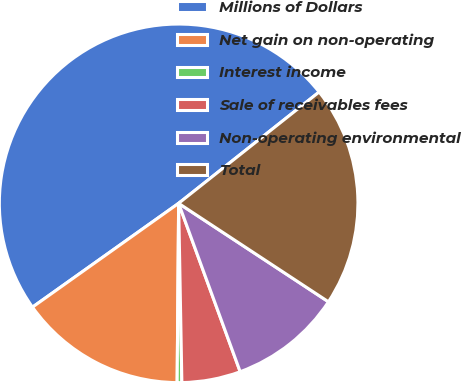<chart> <loc_0><loc_0><loc_500><loc_500><pie_chart><fcel>Millions of Dollars<fcel>Net gain on non-operating<fcel>Interest income<fcel>Sale of receivables fees<fcel>Non-operating environmental<fcel>Total<nl><fcel>49.17%<fcel>15.04%<fcel>0.42%<fcel>5.29%<fcel>10.17%<fcel>19.92%<nl></chart> 